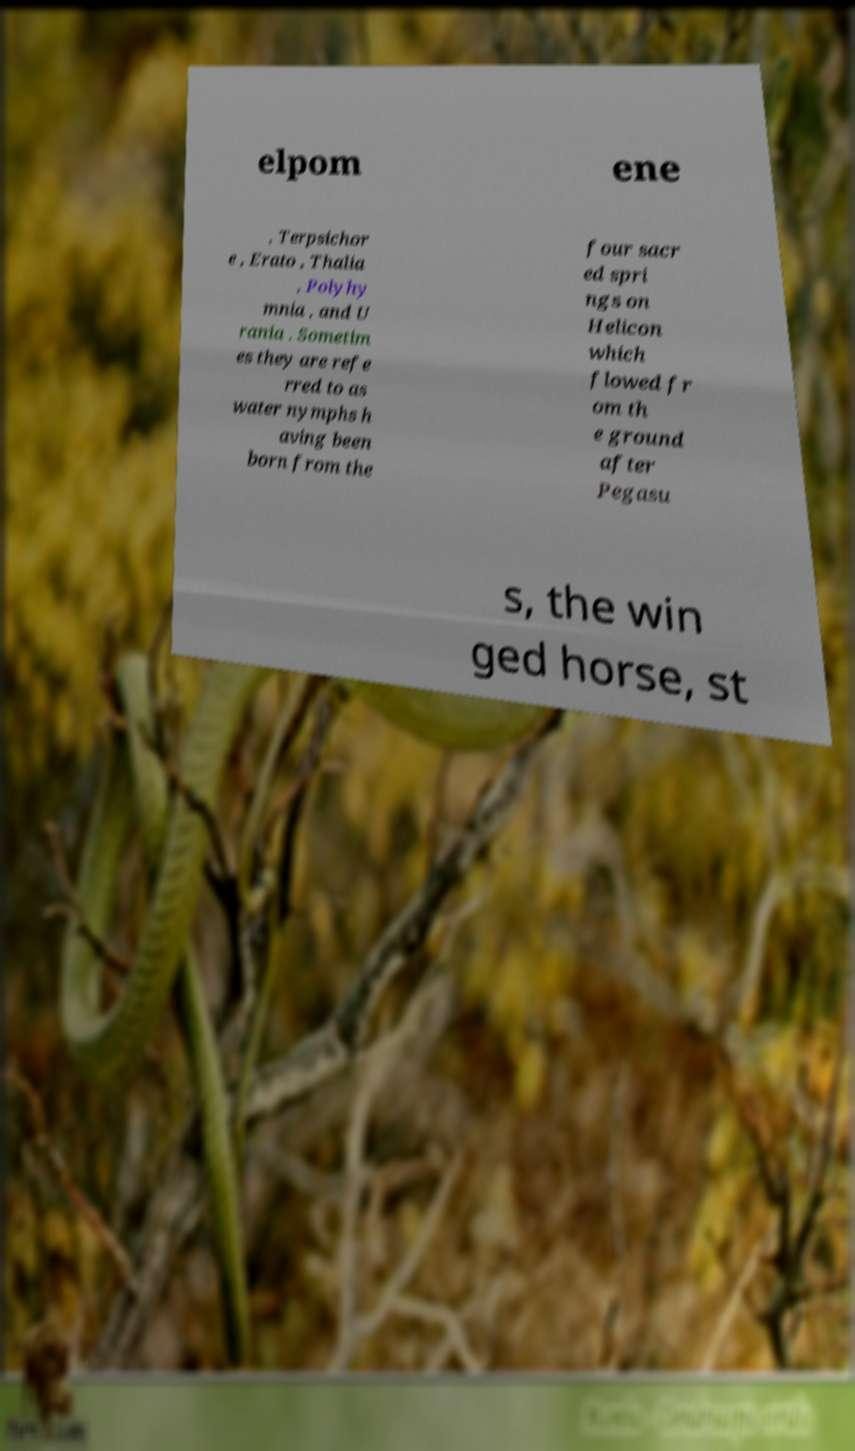Please read and relay the text visible in this image. What does it say? elpom ene , Terpsichor e , Erato , Thalia , Polyhy mnia , and U rania . Sometim es they are refe rred to as water nymphs h aving been born from the four sacr ed spri ngs on Helicon which flowed fr om th e ground after Pegasu s, the win ged horse, st 